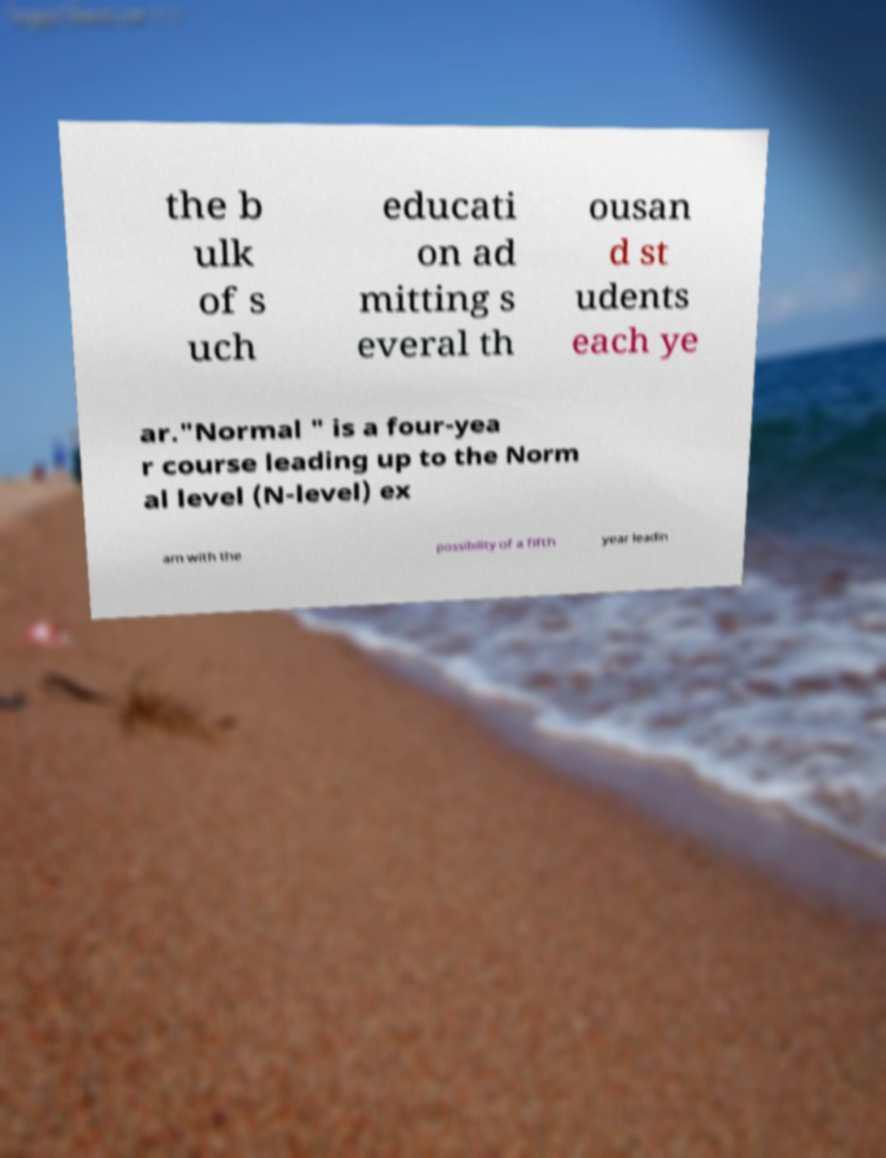Could you assist in decoding the text presented in this image and type it out clearly? the b ulk of s uch educati on ad mitting s everal th ousan d st udents each ye ar."Normal " is a four-yea r course leading up to the Norm al level (N-level) ex am with the possibility of a fifth year leadin 